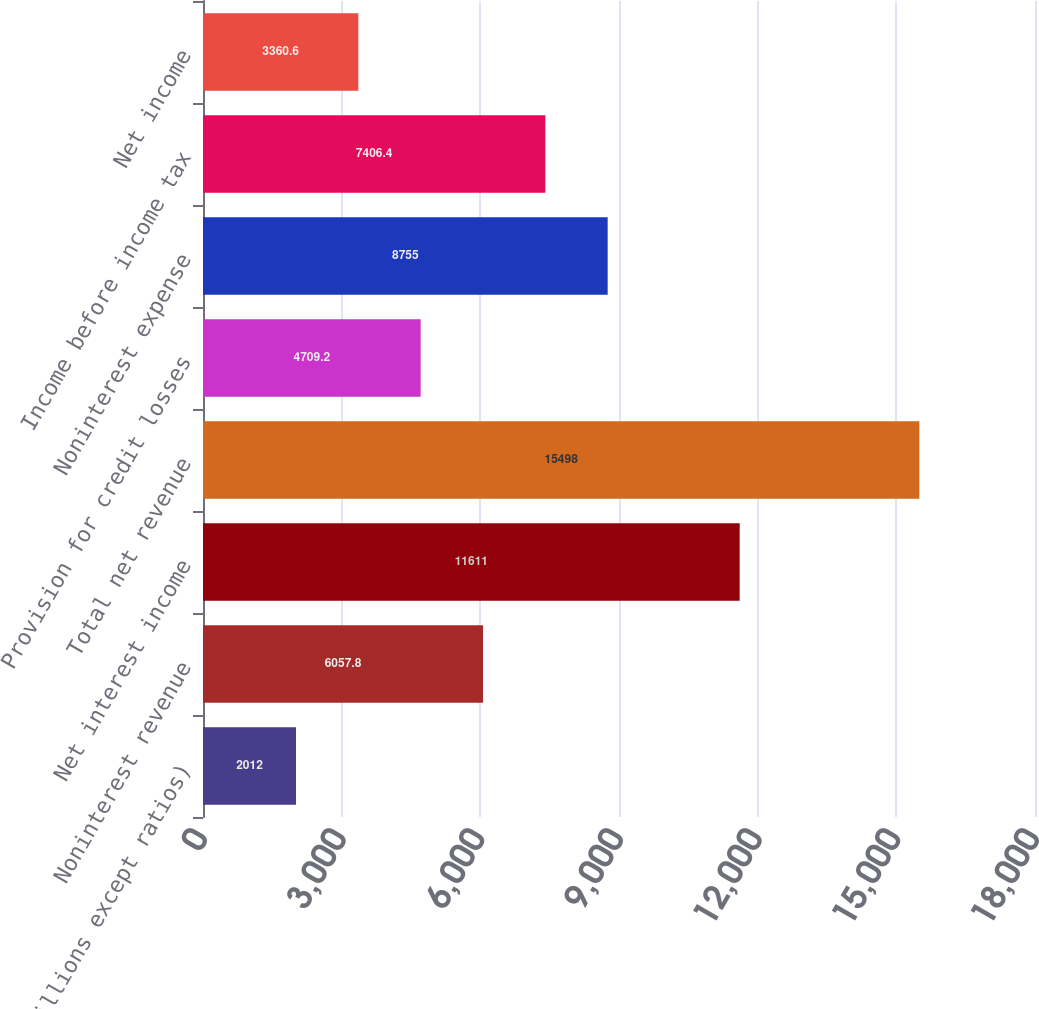<chart> <loc_0><loc_0><loc_500><loc_500><bar_chart><fcel>(in millions except ratios)<fcel>Noninterest revenue<fcel>Net interest income<fcel>Total net revenue<fcel>Provision for credit losses<fcel>Noninterest expense<fcel>Income before income tax<fcel>Net income<nl><fcel>2012<fcel>6057.8<fcel>11611<fcel>15498<fcel>4709.2<fcel>8755<fcel>7406.4<fcel>3360.6<nl></chart> 